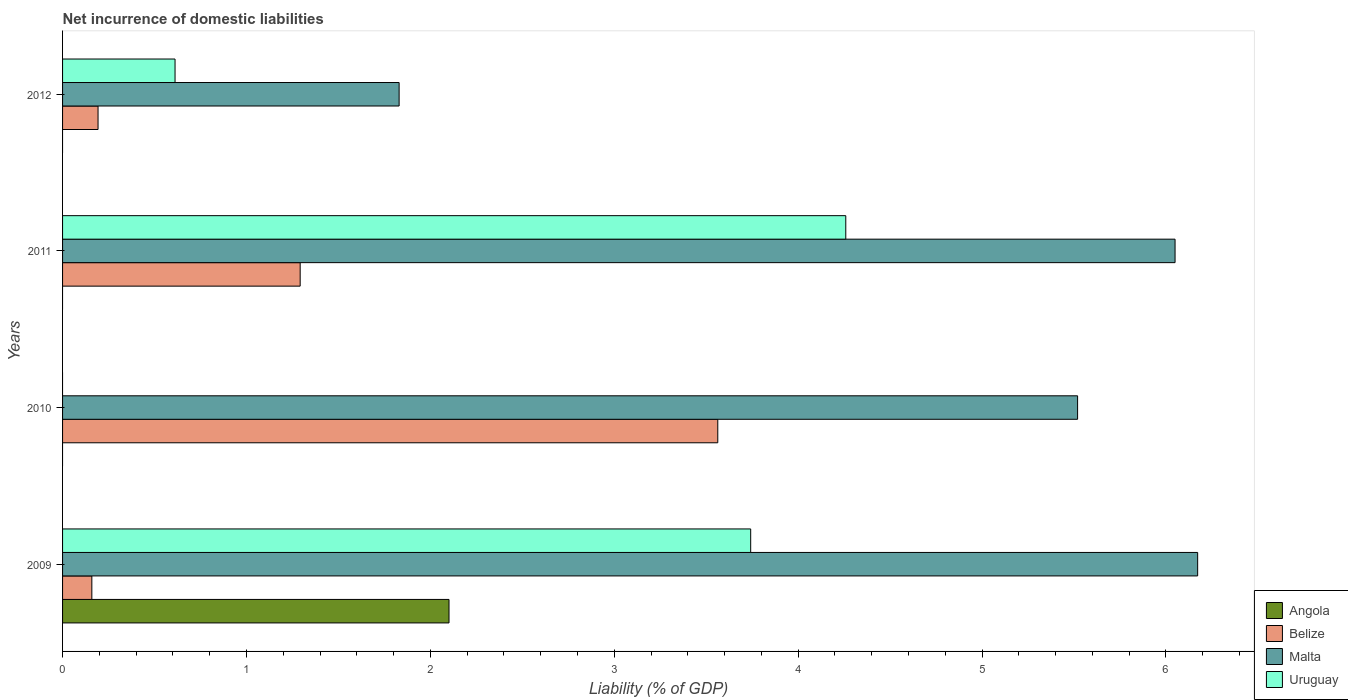How many different coloured bars are there?
Ensure brevity in your answer.  4. How many groups of bars are there?
Keep it short and to the point. 4. Are the number of bars per tick equal to the number of legend labels?
Keep it short and to the point. No. In how many cases, is the number of bars for a given year not equal to the number of legend labels?
Keep it short and to the point. 3. What is the net incurrence of domestic liabilities in Belize in 2010?
Your answer should be compact. 3.56. Across all years, what is the maximum net incurrence of domestic liabilities in Angola?
Offer a very short reply. 2.1. Across all years, what is the minimum net incurrence of domestic liabilities in Belize?
Provide a short and direct response. 0.16. What is the total net incurrence of domestic liabilities in Angola in the graph?
Offer a very short reply. 2.1. What is the difference between the net incurrence of domestic liabilities in Uruguay in 2009 and that in 2011?
Offer a very short reply. -0.52. What is the difference between the net incurrence of domestic liabilities in Malta in 2010 and the net incurrence of domestic liabilities in Angola in 2011?
Provide a short and direct response. 5.52. What is the average net incurrence of domestic liabilities in Angola per year?
Keep it short and to the point. 0.53. In the year 2012, what is the difference between the net incurrence of domestic liabilities in Malta and net incurrence of domestic liabilities in Uruguay?
Provide a succinct answer. 1.22. What is the ratio of the net incurrence of domestic liabilities in Belize in 2009 to that in 2011?
Your answer should be very brief. 0.12. Is the net incurrence of domestic liabilities in Malta in 2010 less than that in 2012?
Offer a terse response. No. What is the difference between the highest and the second highest net incurrence of domestic liabilities in Belize?
Keep it short and to the point. 2.27. What is the difference between the highest and the lowest net incurrence of domestic liabilities in Uruguay?
Offer a terse response. 4.26. In how many years, is the net incurrence of domestic liabilities in Angola greater than the average net incurrence of domestic liabilities in Angola taken over all years?
Your answer should be compact. 1. Is it the case that in every year, the sum of the net incurrence of domestic liabilities in Belize and net incurrence of domestic liabilities in Uruguay is greater than the sum of net incurrence of domestic liabilities in Angola and net incurrence of domestic liabilities in Malta?
Your answer should be compact. No. How many bars are there?
Make the answer very short. 12. Are all the bars in the graph horizontal?
Give a very brief answer. Yes. Are the values on the major ticks of X-axis written in scientific E-notation?
Make the answer very short. No. Does the graph contain grids?
Provide a short and direct response. No. What is the title of the graph?
Offer a very short reply. Net incurrence of domestic liabilities. Does "Europe(all income levels)" appear as one of the legend labels in the graph?
Provide a succinct answer. No. What is the label or title of the X-axis?
Keep it short and to the point. Liability (% of GDP). What is the Liability (% of GDP) of Angola in 2009?
Offer a terse response. 2.1. What is the Liability (% of GDP) in Belize in 2009?
Make the answer very short. 0.16. What is the Liability (% of GDP) of Malta in 2009?
Give a very brief answer. 6.17. What is the Liability (% of GDP) of Uruguay in 2009?
Your answer should be compact. 3.74. What is the Liability (% of GDP) of Angola in 2010?
Your response must be concise. 0. What is the Liability (% of GDP) of Belize in 2010?
Make the answer very short. 3.56. What is the Liability (% of GDP) of Malta in 2010?
Keep it short and to the point. 5.52. What is the Liability (% of GDP) in Angola in 2011?
Make the answer very short. 0. What is the Liability (% of GDP) in Belize in 2011?
Your answer should be very brief. 1.29. What is the Liability (% of GDP) in Malta in 2011?
Keep it short and to the point. 6.05. What is the Liability (% of GDP) in Uruguay in 2011?
Keep it short and to the point. 4.26. What is the Liability (% of GDP) of Angola in 2012?
Give a very brief answer. 0. What is the Liability (% of GDP) in Belize in 2012?
Your answer should be very brief. 0.19. What is the Liability (% of GDP) of Malta in 2012?
Make the answer very short. 1.83. What is the Liability (% of GDP) of Uruguay in 2012?
Your response must be concise. 0.61. Across all years, what is the maximum Liability (% of GDP) of Angola?
Your answer should be compact. 2.1. Across all years, what is the maximum Liability (% of GDP) in Belize?
Provide a succinct answer. 3.56. Across all years, what is the maximum Liability (% of GDP) in Malta?
Offer a terse response. 6.17. Across all years, what is the maximum Liability (% of GDP) of Uruguay?
Provide a short and direct response. 4.26. Across all years, what is the minimum Liability (% of GDP) in Angola?
Make the answer very short. 0. Across all years, what is the minimum Liability (% of GDP) in Belize?
Your answer should be very brief. 0.16. Across all years, what is the minimum Liability (% of GDP) of Malta?
Offer a very short reply. 1.83. Across all years, what is the minimum Liability (% of GDP) of Uruguay?
Offer a very short reply. 0. What is the total Liability (% of GDP) in Angola in the graph?
Offer a terse response. 2.1. What is the total Liability (% of GDP) in Belize in the graph?
Make the answer very short. 5.21. What is the total Liability (% of GDP) in Malta in the graph?
Keep it short and to the point. 19.57. What is the total Liability (% of GDP) in Uruguay in the graph?
Offer a very short reply. 8.61. What is the difference between the Liability (% of GDP) of Belize in 2009 and that in 2010?
Offer a terse response. -3.4. What is the difference between the Liability (% of GDP) of Malta in 2009 and that in 2010?
Ensure brevity in your answer.  0.65. What is the difference between the Liability (% of GDP) in Belize in 2009 and that in 2011?
Your answer should be very brief. -1.13. What is the difference between the Liability (% of GDP) of Malta in 2009 and that in 2011?
Give a very brief answer. 0.12. What is the difference between the Liability (% of GDP) of Uruguay in 2009 and that in 2011?
Give a very brief answer. -0.52. What is the difference between the Liability (% of GDP) of Belize in 2009 and that in 2012?
Your answer should be compact. -0.03. What is the difference between the Liability (% of GDP) in Malta in 2009 and that in 2012?
Offer a very short reply. 4.34. What is the difference between the Liability (% of GDP) in Uruguay in 2009 and that in 2012?
Make the answer very short. 3.13. What is the difference between the Liability (% of GDP) in Belize in 2010 and that in 2011?
Ensure brevity in your answer.  2.27. What is the difference between the Liability (% of GDP) in Malta in 2010 and that in 2011?
Offer a very short reply. -0.53. What is the difference between the Liability (% of GDP) in Belize in 2010 and that in 2012?
Give a very brief answer. 3.37. What is the difference between the Liability (% of GDP) in Malta in 2010 and that in 2012?
Provide a short and direct response. 3.69. What is the difference between the Liability (% of GDP) in Belize in 2011 and that in 2012?
Your answer should be very brief. 1.1. What is the difference between the Liability (% of GDP) in Malta in 2011 and that in 2012?
Provide a succinct answer. 4.22. What is the difference between the Liability (% of GDP) in Uruguay in 2011 and that in 2012?
Offer a very short reply. 3.65. What is the difference between the Liability (% of GDP) in Angola in 2009 and the Liability (% of GDP) in Belize in 2010?
Your answer should be very brief. -1.46. What is the difference between the Liability (% of GDP) in Angola in 2009 and the Liability (% of GDP) in Malta in 2010?
Give a very brief answer. -3.42. What is the difference between the Liability (% of GDP) of Belize in 2009 and the Liability (% of GDP) of Malta in 2010?
Your response must be concise. -5.36. What is the difference between the Liability (% of GDP) in Angola in 2009 and the Liability (% of GDP) in Belize in 2011?
Your response must be concise. 0.81. What is the difference between the Liability (% of GDP) in Angola in 2009 and the Liability (% of GDP) in Malta in 2011?
Give a very brief answer. -3.95. What is the difference between the Liability (% of GDP) of Angola in 2009 and the Liability (% of GDP) of Uruguay in 2011?
Offer a very short reply. -2.16. What is the difference between the Liability (% of GDP) of Belize in 2009 and the Liability (% of GDP) of Malta in 2011?
Offer a terse response. -5.89. What is the difference between the Liability (% of GDP) in Belize in 2009 and the Liability (% of GDP) in Uruguay in 2011?
Ensure brevity in your answer.  -4.1. What is the difference between the Liability (% of GDP) of Malta in 2009 and the Liability (% of GDP) of Uruguay in 2011?
Ensure brevity in your answer.  1.91. What is the difference between the Liability (% of GDP) of Angola in 2009 and the Liability (% of GDP) of Belize in 2012?
Offer a terse response. 1.91. What is the difference between the Liability (% of GDP) in Angola in 2009 and the Liability (% of GDP) in Malta in 2012?
Your answer should be very brief. 0.27. What is the difference between the Liability (% of GDP) in Angola in 2009 and the Liability (% of GDP) in Uruguay in 2012?
Make the answer very short. 1.49. What is the difference between the Liability (% of GDP) of Belize in 2009 and the Liability (% of GDP) of Malta in 2012?
Your response must be concise. -1.67. What is the difference between the Liability (% of GDP) of Belize in 2009 and the Liability (% of GDP) of Uruguay in 2012?
Keep it short and to the point. -0.45. What is the difference between the Liability (% of GDP) in Malta in 2009 and the Liability (% of GDP) in Uruguay in 2012?
Give a very brief answer. 5.56. What is the difference between the Liability (% of GDP) in Belize in 2010 and the Liability (% of GDP) in Malta in 2011?
Make the answer very short. -2.49. What is the difference between the Liability (% of GDP) of Belize in 2010 and the Liability (% of GDP) of Uruguay in 2011?
Ensure brevity in your answer.  -0.7. What is the difference between the Liability (% of GDP) of Malta in 2010 and the Liability (% of GDP) of Uruguay in 2011?
Offer a terse response. 1.26. What is the difference between the Liability (% of GDP) of Belize in 2010 and the Liability (% of GDP) of Malta in 2012?
Provide a succinct answer. 1.73. What is the difference between the Liability (% of GDP) in Belize in 2010 and the Liability (% of GDP) in Uruguay in 2012?
Make the answer very short. 2.95. What is the difference between the Liability (% of GDP) in Malta in 2010 and the Liability (% of GDP) in Uruguay in 2012?
Make the answer very short. 4.91. What is the difference between the Liability (% of GDP) in Belize in 2011 and the Liability (% of GDP) in Malta in 2012?
Make the answer very short. -0.54. What is the difference between the Liability (% of GDP) in Belize in 2011 and the Liability (% of GDP) in Uruguay in 2012?
Give a very brief answer. 0.68. What is the difference between the Liability (% of GDP) of Malta in 2011 and the Liability (% of GDP) of Uruguay in 2012?
Provide a succinct answer. 5.44. What is the average Liability (% of GDP) of Angola per year?
Provide a short and direct response. 0.53. What is the average Liability (% of GDP) in Belize per year?
Give a very brief answer. 1.3. What is the average Liability (% of GDP) in Malta per year?
Offer a terse response. 4.89. What is the average Liability (% of GDP) in Uruguay per year?
Offer a terse response. 2.15. In the year 2009, what is the difference between the Liability (% of GDP) in Angola and Liability (% of GDP) in Belize?
Give a very brief answer. 1.94. In the year 2009, what is the difference between the Liability (% of GDP) in Angola and Liability (% of GDP) in Malta?
Your answer should be compact. -4.07. In the year 2009, what is the difference between the Liability (% of GDP) of Angola and Liability (% of GDP) of Uruguay?
Your answer should be very brief. -1.64. In the year 2009, what is the difference between the Liability (% of GDP) of Belize and Liability (% of GDP) of Malta?
Offer a very short reply. -6.01. In the year 2009, what is the difference between the Liability (% of GDP) of Belize and Liability (% of GDP) of Uruguay?
Make the answer very short. -3.58. In the year 2009, what is the difference between the Liability (% of GDP) in Malta and Liability (% of GDP) in Uruguay?
Make the answer very short. 2.43. In the year 2010, what is the difference between the Liability (% of GDP) in Belize and Liability (% of GDP) in Malta?
Your answer should be very brief. -1.96. In the year 2011, what is the difference between the Liability (% of GDP) in Belize and Liability (% of GDP) in Malta?
Offer a very short reply. -4.76. In the year 2011, what is the difference between the Liability (% of GDP) of Belize and Liability (% of GDP) of Uruguay?
Your response must be concise. -2.97. In the year 2011, what is the difference between the Liability (% of GDP) in Malta and Liability (% of GDP) in Uruguay?
Make the answer very short. 1.79. In the year 2012, what is the difference between the Liability (% of GDP) in Belize and Liability (% of GDP) in Malta?
Offer a very short reply. -1.64. In the year 2012, what is the difference between the Liability (% of GDP) of Belize and Liability (% of GDP) of Uruguay?
Your answer should be very brief. -0.42. In the year 2012, what is the difference between the Liability (% of GDP) of Malta and Liability (% of GDP) of Uruguay?
Offer a terse response. 1.22. What is the ratio of the Liability (% of GDP) in Belize in 2009 to that in 2010?
Keep it short and to the point. 0.04. What is the ratio of the Liability (% of GDP) of Malta in 2009 to that in 2010?
Ensure brevity in your answer.  1.12. What is the ratio of the Liability (% of GDP) in Belize in 2009 to that in 2011?
Offer a very short reply. 0.12. What is the ratio of the Liability (% of GDP) of Malta in 2009 to that in 2011?
Give a very brief answer. 1.02. What is the ratio of the Liability (% of GDP) in Uruguay in 2009 to that in 2011?
Ensure brevity in your answer.  0.88. What is the ratio of the Liability (% of GDP) in Belize in 2009 to that in 2012?
Your response must be concise. 0.82. What is the ratio of the Liability (% of GDP) of Malta in 2009 to that in 2012?
Your response must be concise. 3.37. What is the ratio of the Liability (% of GDP) in Uruguay in 2009 to that in 2012?
Your response must be concise. 6.12. What is the ratio of the Liability (% of GDP) of Belize in 2010 to that in 2011?
Provide a succinct answer. 2.76. What is the ratio of the Liability (% of GDP) of Malta in 2010 to that in 2011?
Give a very brief answer. 0.91. What is the ratio of the Liability (% of GDP) in Belize in 2010 to that in 2012?
Your response must be concise. 18.46. What is the ratio of the Liability (% of GDP) in Malta in 2010 to that in 2012?
Provide a short and direct response. 3.02. What is the ratio of the Liability (% of GDP) in Belize in 2011 to that in 2012?
Your answer should be compact. 6.7. What is the ratio of the Liability (% of GDP) of Malta in 2011 to that in 2012?
Make the answer very short. 3.31. What is the ratio of the Liability (% of GDP) of Uruguay in 2011 to that in 2012?
Ensure brevity in your answer.  6.96. What is the difference between the highest and the second highest Liability (% of GDP) of Belize?
Ensure brevity in your answer.  2.27. What is the difference between the highest and the second highest Liability (% of GDP) of Malta?
Your answer should be very brief. 0.12. What is the difference between the highest and the second highest Liability (% of GDP) of Uruguay?
Keep it short and to the point. 0.52. What is the difference between the highest and the lowest Liability (% of GDP) in Angola?
Make the answer very short. 2.1. What is the difference between the highest and the lowest Liability (% of GDP) of Belize?
Keep it short and to the point. 3.4. What is the difference between the highest and the lowest Liability (% of GDP) of Malta?
Make the answer very short. 4.34. What is the difference between the highest and the lowest Liability (% of GDP) in Uruguay?
Offer a terse response. 4.26. 